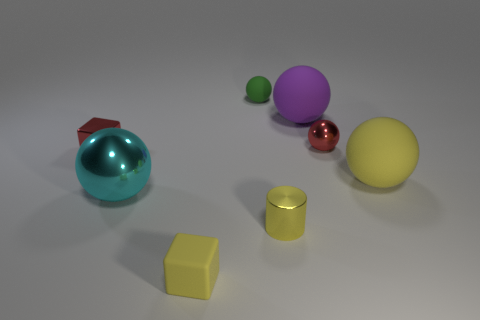What color is the shiny cylinder that is the same size as the yellow matte cube?
Provide a short and direct response. Yellow. How many blue rubber objects are the same shape as the large yellow rubber thing?
Your answer should be compact. 0. What number of cylinders are either yellow objects or big objects?
Your response must be concise. 1. There is a big rubber thing on the left side of the red shiny sphere; is its shape the same as the small matte thing that is behind the large yellow rubber thing?
Provide a succinct answer. Yes. What is the material of the large cyan thing?
Your answer should be compact. Metal. What shape is the big rubber thing that is the same color as the cylinder?
Keep it short and to the point. Sphere. What number of cubes have the same size as the red metal ball?
Keep it short and to the point. 2. What number of things are either small blocks that are left of the cyan metal sphere or balls that are in front of the red shiny block?
Keep it short and to the point. 3. Is the block in front of the large cyan sphere made of the same material as the yellow object behind the big cyan ball?
Offer a very short reply. Yes. There is a big rubber object to the left of the shiny ball that is on the right side of the yellow cylinder; what is its shape?
Offer a terse response. Sphere. 